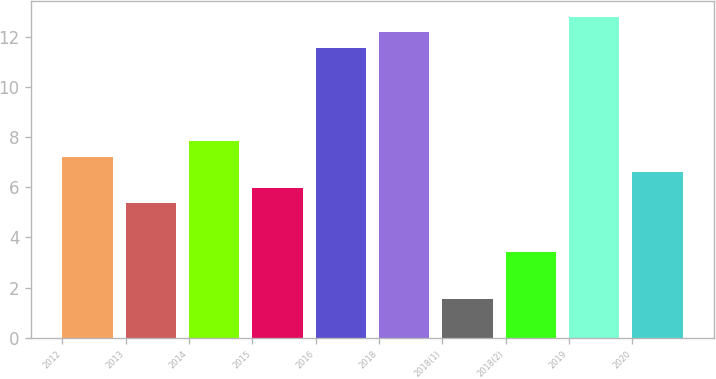<chart> <loc_0><loc_0><loc_500><loc_500><bar_chart><fcel>2012<fcel>2013<fcel>2014<fcel>2015<fcel>2016<fcel>2018<fcel>2018(1)<fcel>2018(2)<fcel>2019<fcel>2020<nl><fcel>7.23<fcel>5.37<fcel>7.85<fcel>5.99<fcel>11.57<fcel>12.19<fcel>1.56<fcel>3.42<fcel>12.81<fcel>6.61<nl></chart> 